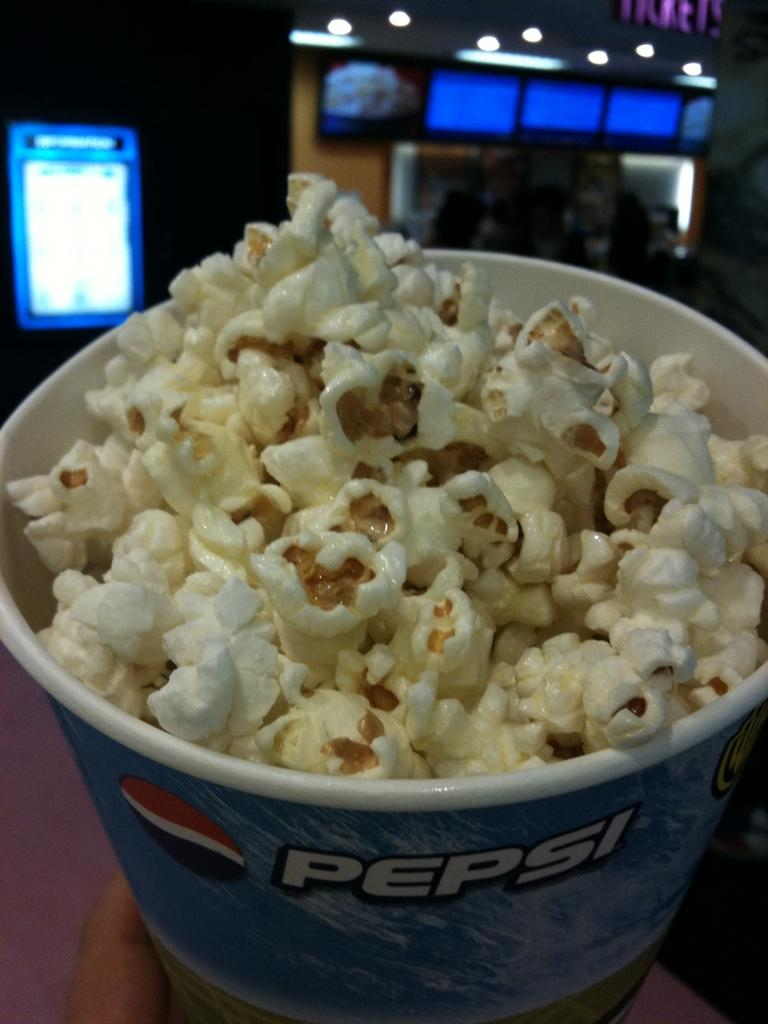What type of container is in the image? There is a paper bucket in the image. What is written on the bucket? There is a word written on the bucket. What else is featured on the bucket besides the word? There is a logo on the bucket. What is inside the bucket? There is popcorn in the bucket. What can be seen in the background of the image? There are lights and screens visible in the background of the image. How does the toe of the person in the image affect the taste of the popcorn? There is no person present in the image, and therefore no toe to affect the taste of the popcorn. 